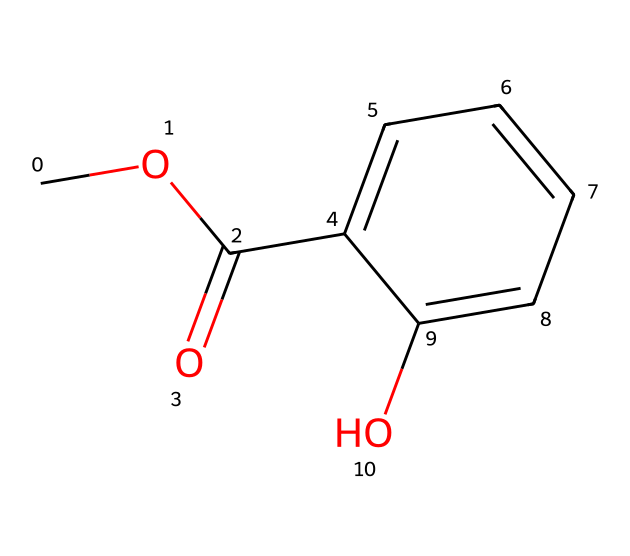What is the molecular formula of the compound? The compound can be analyzed to count the number of carbon (C), hydrogen (H), and oxygen (O) atoms based on the SMILES representation. This SMILES represents 10 carbon atoms, 10 hydrogen atoms, and 3 oxygen atoms, yielding the molecular formula C10H10O3.
Answer: C10H10O3 How many rings are present in the structure? Looking at the chemical structure derived from the SMILES notation, there is one cyclic component, which is represented by "C1" indicating the start of a ring and then returning to "C1" later in the structure.
Answer: 1 What type of functional group is present in the structure? The presence of "C(=O)" indicates a carbonyl functional group (specifically, a carbonyl within a carboxylic acid or ester), and the "O" linked to a phenolic structure ("C1=CC=CC=C1O") suggests a hydroxyl group. Thus, the compound contains an ester functional group.
Answer: ester Which part of the molecule is responsible for its topical application? The hydroxyl group (-OH) is often responsible for solubility and absorption properties of topical ointments, enhancing interaction with biological tissues. The presence of the phenolic compound (the benzene ring with -OH) aids in the ointment's efficacy.
Answer: hydroxyl group What is the total number of bonds in the structure? To determine the total number of bonds, we can analyze the number of each type of bond in the molecule: single and double bonds as depicted in the SMILES. The structure indicates 12 single bonds and 2 double bonds, totaling 14 bonds.
Answer: 14 Are there any chiral centers in this compound? To determine chirality, we check for any carbon atoms bonded to four different substituents. In this molecule, all the carbon centers are either part of rings or have repetitive substituents, thus there are no chiral centers present.
Answer: No 